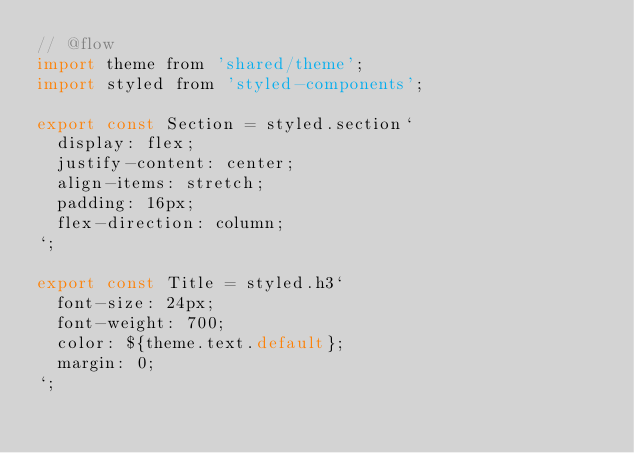Convert code to text. <code><loc_0><loc_0><loc_500><loc_500><_JavaScript_>// @flow
import theme from 'shared/theme';
import styled from 'styled-components';

export const Section = styled.section`
  display: flex;
  justify-content: center;
  align-items: stretch;
  padding: 16px;
  flex-direction: column;
`;

export const Title = styled.h3`
  font-size: 24px;
  font-weight: 700;
  color: ${theme.text.default};
  margin: 0;
`;
</code> 